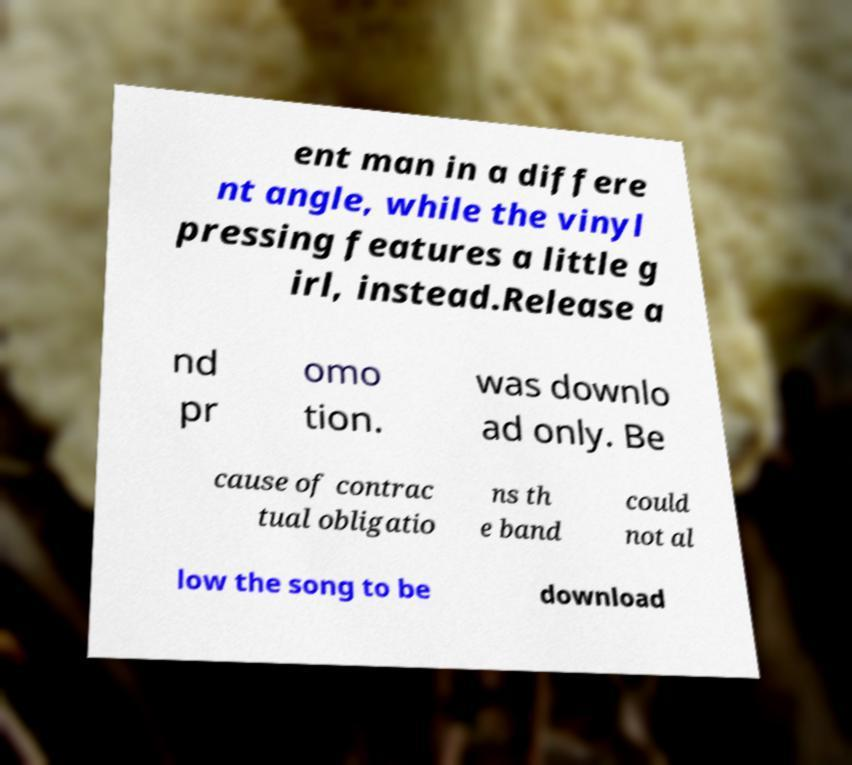For documentation purposes, I need the text within this image transcribed. Could you provide that? ent man in a differe nt angle, while the vinyl pressing features a little g irl, instead.Release a nd pr omo tion. was downlo ad only. Be cause of contrac tual obligatio ns th e band could not al low the song to be download 